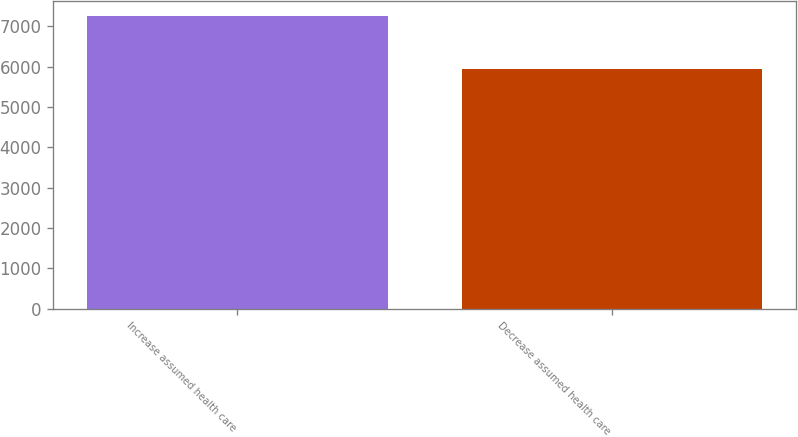<chart> <loc_0><loc_0><loc_500><loc_500><bar_chart><fcel>Increase assumed health care<fcel>Decrease assumed health care<nl><fcel>7253<fcel>5928<nl></chart> 